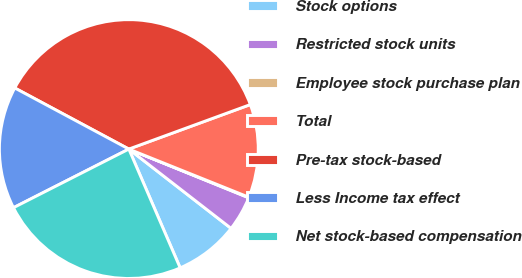Convert chart to OTSL. <chart><loc_0><loc_0><loc_500><loc_500><pie_chart><fcel>Stock options<fcel>Restricted stock units<fcel>Employee stock purchase plan<fcel>Total<fcel>Pre-tax stock-based<fcel>Less Income tax effect<fcel>Net stock-based compensation<nl><fcel>8.01%<fcel>4.36%<fcel>0.07%<fcel>11.66%<fcel>36.59%<fcel>15.31%<fcel>24.01%<nl></chart> 